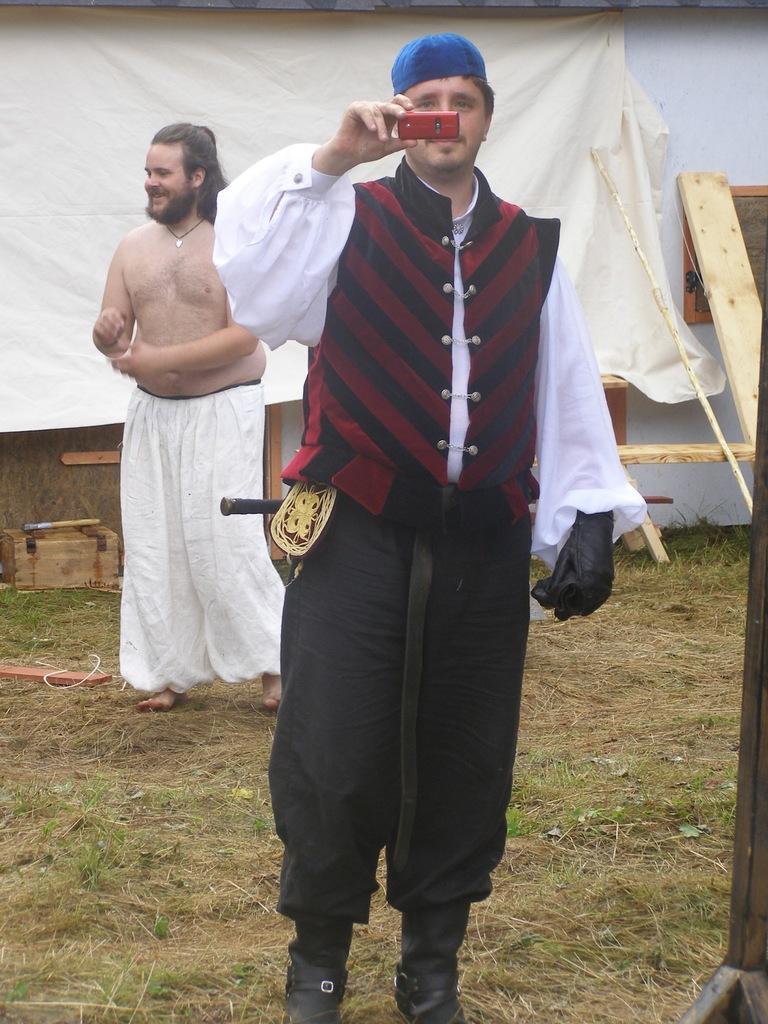Can you describe this image briefly? In this picture there is a person standing and holding a mobile in his hand and there is another person standing behind him and there are some other objects in the background. 